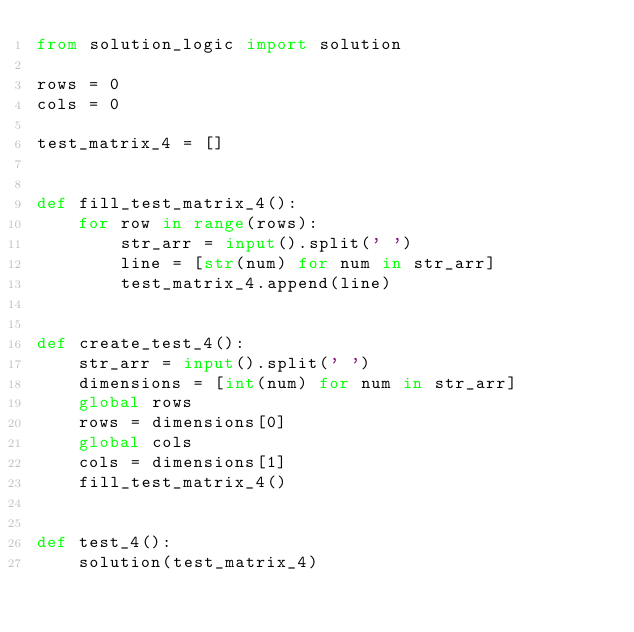Convert code to text. <code><loc_0><loc_0><loc_500><loc_500><_Python_>from solution_logic import solution

rows = 0
cols = 0

test_matrix_4 = []


def fill_test_matrix_4():
    for row in range(rows):
        str_arr = input().split(' ')
        line = [str(num) for num in str_arr]
        test_matrix_4.append(line)


def create_test_4():
    str_arr = input().split(' ')
    dimensions = [int(num) for num in str_arr]
    global rows
    rows = dimensions[0]
    global cols
    cols = dimensions[1]
    fill_test_matrix_4()


def test_4():
    solution(test_matrix_4)
</code> 